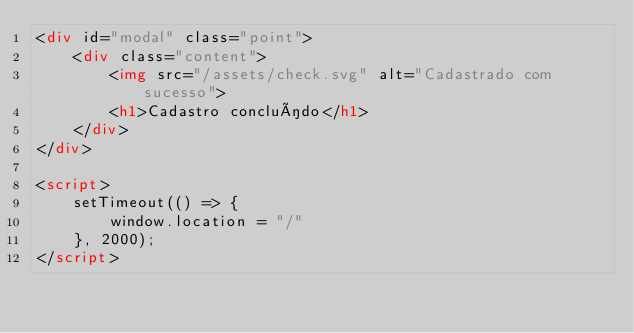Convert code to text. <code><loc_0><loc_0><loc_500><loc_500><_HTML_><div id="modal" class="point">
    <div class="content">
        <img src="/assets/check.svg" alt="Cadastrado com sucesso">
        <h1>Cadastro concluído</h1>
    </div>
</div>

<script>
    setTimeout(() => {
        window.location = "/"
    }, 2000);
</script></code> 